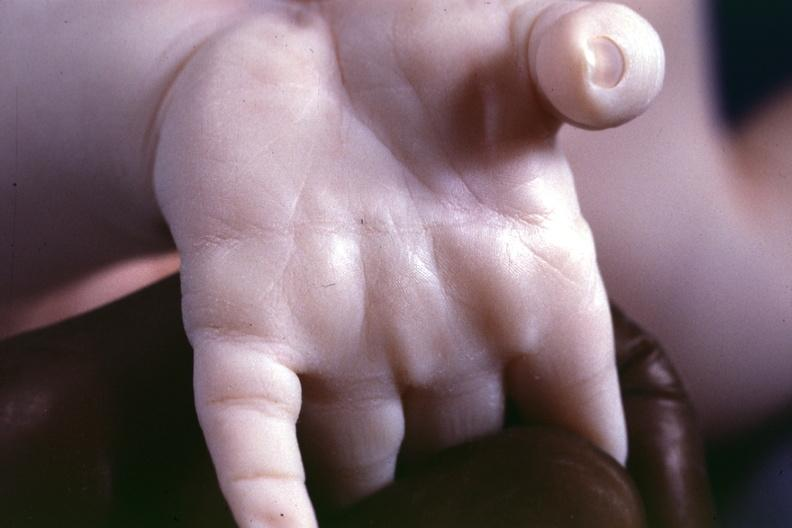what is present?
Answer the question using a single word or phrase. Simian crease 